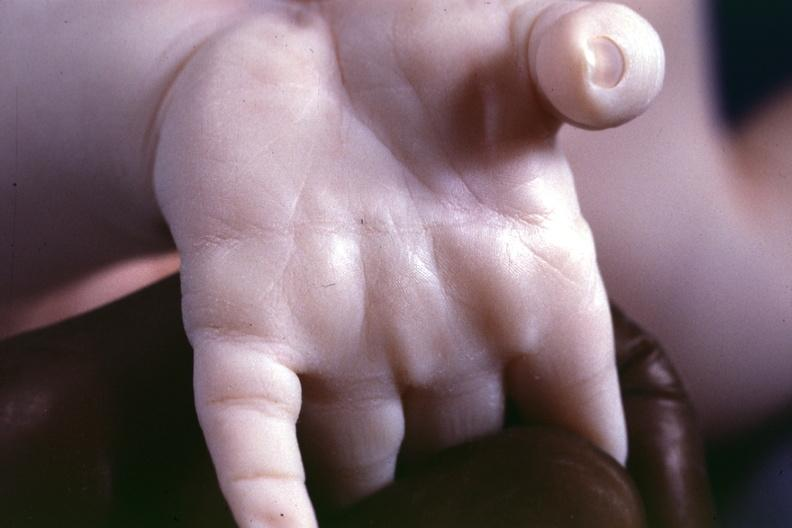what is present?
Answer the question using a single word or phrase. Simian crease 